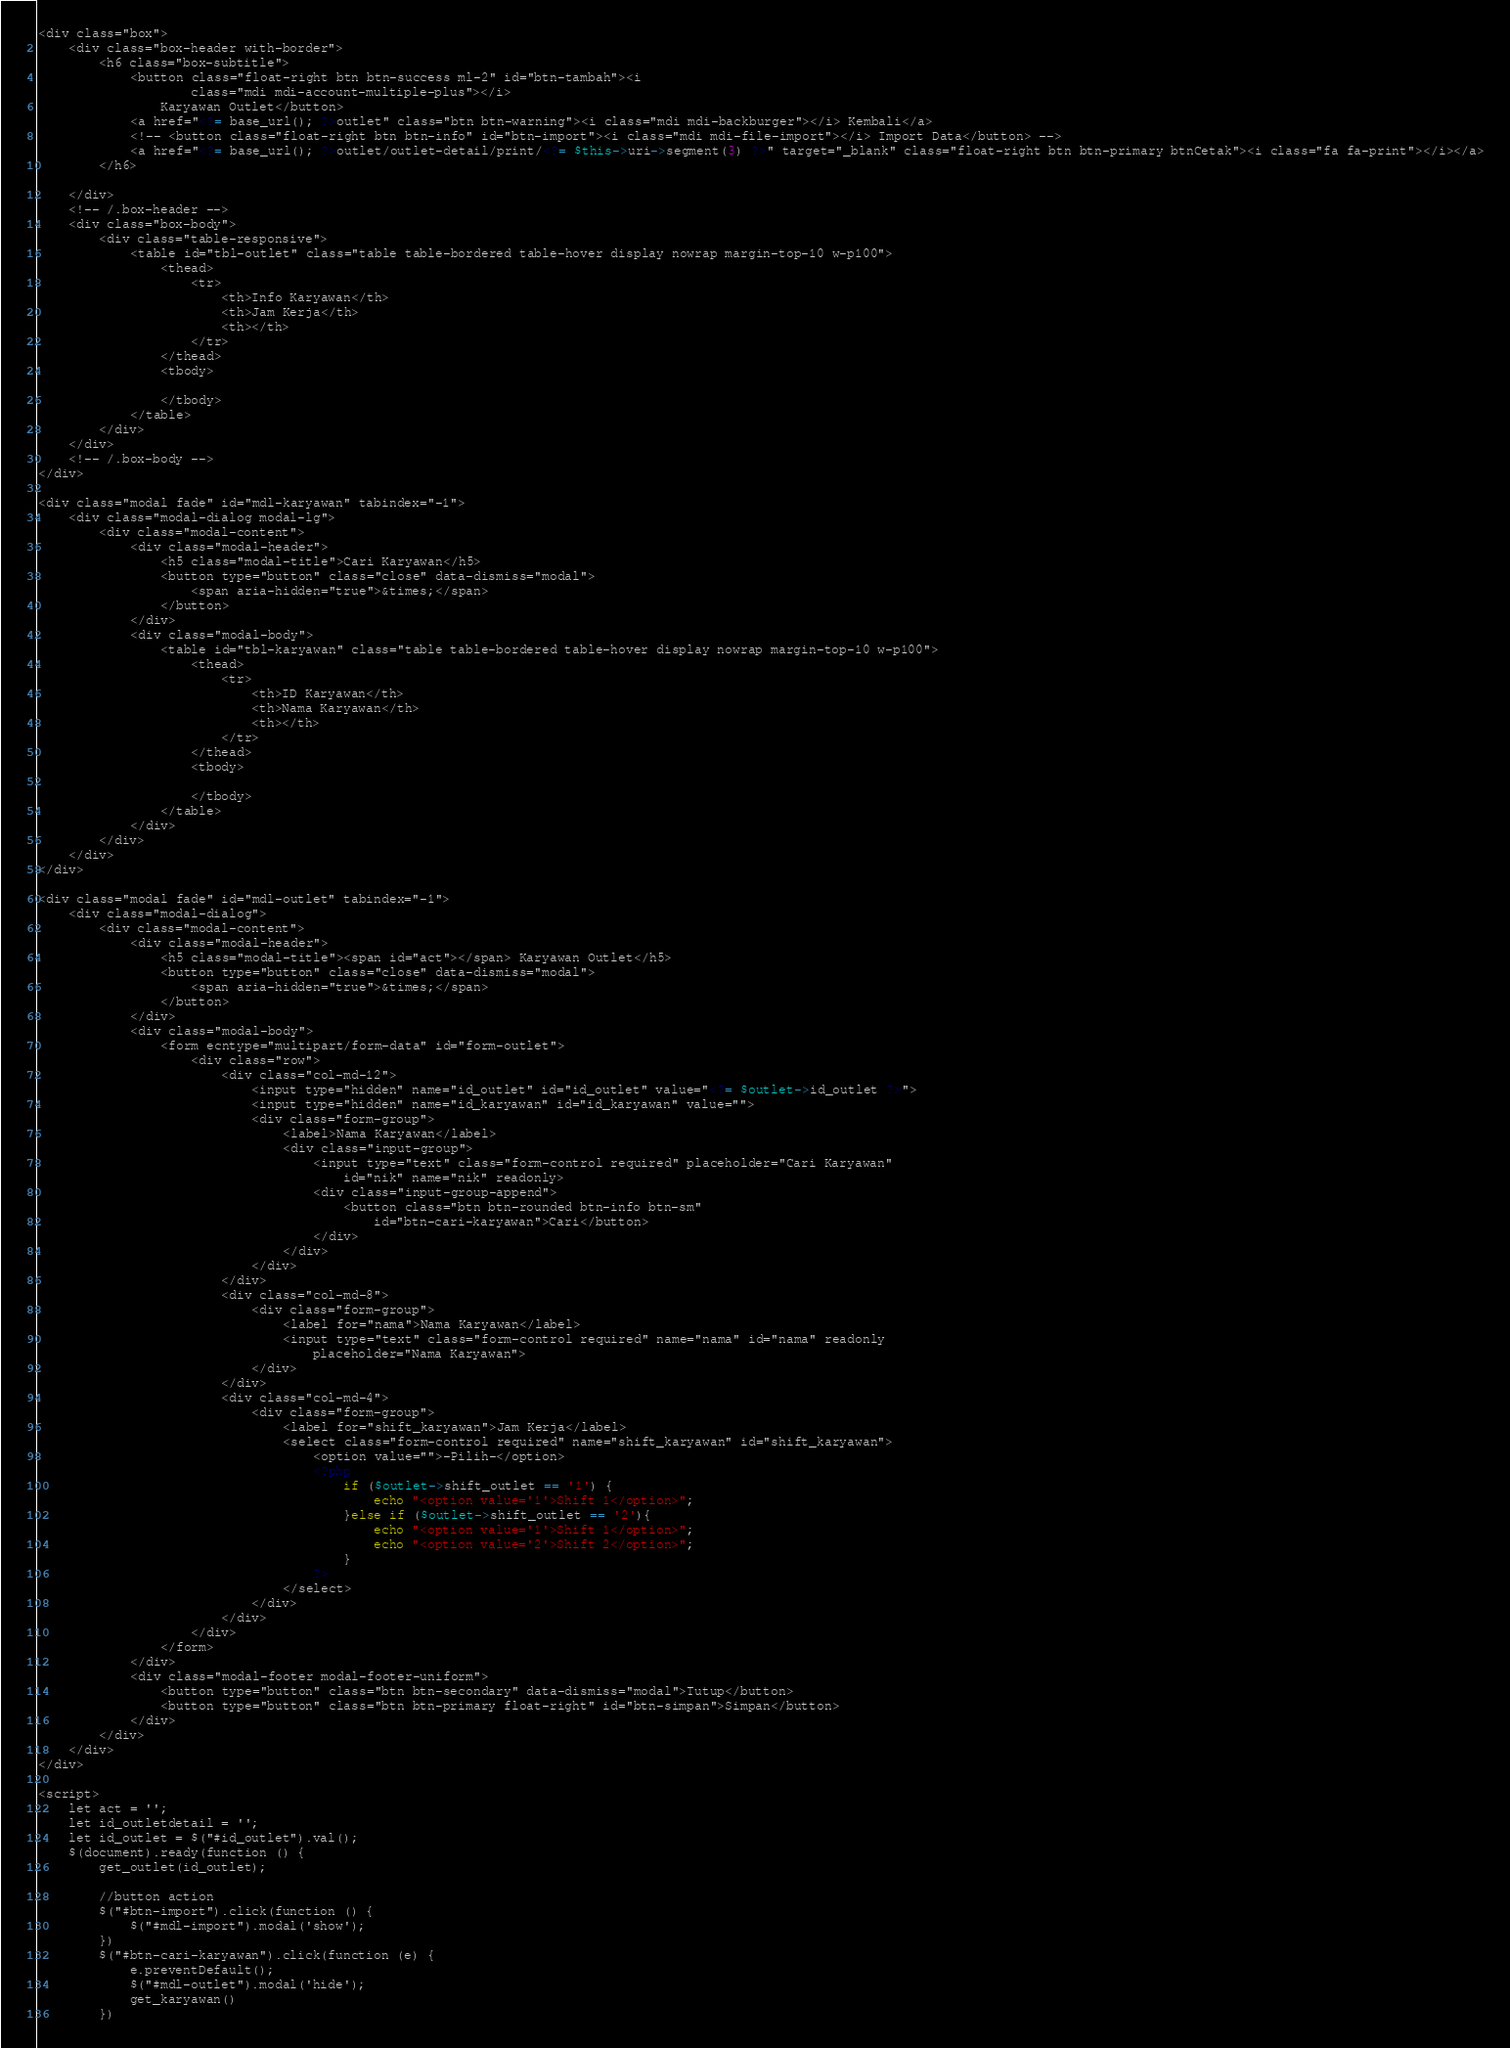Convert code to text. <code><loc_0><loc_0><loc_500><loc_500><_PHP_><div class="box">
	<div class="box-header with-border">
		<h6 class="box-subtitle">
			<button class="float-right btn btn-success ml-2" id="btn-tambah"><i
					class="mdi mdi-account-multiple-plus"></i>
				Karyawan Outlet</button>
			<a href="<?= base_url(); ?>outlet" class="btn btn-warning"><i class="mdi mdi-backburger"></i> Kembali</a>
			<!-- <button class="float-right btn btn-info" id="btn-import"><i class="mdi mdi-file-import"></i> Import Data</button> -->
			<a href="<?= base_url(); ?>outlet/outlet-detail/print/<?= $this->uri->segment(3) ?>" target="_blank" class="float-right btn btn-primary btnCetak"><i class="fa fa-print"></i></a>
		</h6>

	</div>
	<!-- /.box-header -->
	<div class="box-body">
		<div class="table-responsive">
			<table id="tbl-outlet" class="table table-bordered table-hover display nowrap margin-top-10 w-p100">
				<thead>
					<tr>
						<th>Info Karyawan</th>
						<th>Jam Kerja</th>
						<th></th>
					</tr>
				</thead>
				<tbody>

				</tbody>
			</table>
		</div>
	</div>
	<!-- /.box-body -->
</div>

<div class="modal fade" id="mdl-karyawan" tabindex="-1">
	<div class="modal-dialog modal-lg">
		<div class="modal-content">
			<div class="modal-header">
				<h5 class="modal-title">Cari Karyawan</h5>
				<button type="button" class="close" data-dismiss="modal">
					<span aria-hidden="true">&times;</span>
				</button>
			</div>
			<div class="modal-body">
				<table id="tbl-karyawan" class="table table-bordered table-hover display nowrap margin-top-10 w-p100">
					<thead>
						<tr>
							<th>ID Karyawan</th>
							<th>Nama Karyawan</th>
							<th></th>
						</tr>
					</thead>
					<tbody>

					</tbody>
				</table>
			</div>
		</div>
	</div>
</div>

<div class="modal fade" id="mdl-outlet" tabindex="-1">
	<div class="modal-dialog">
		<div class="modal-content">
			<div class="modal-header">
				<h5 class="modal-title"><span id="act"></span> Karyawan Outlet</h5>
				<button type="button" class="close" data-dismiss="modal">
					<span aria-hidden="true">&times;</span>
				</button>
			</div>
			<div class="modal-body">
				<form ecntype="multipart/form-data" id="form-outlet">
					<div class="row">
						<div class="col-md-12">
							<input type="hidden" name="id_outlet" id="id_outlet" value="<?= $outlet->id_outlet ?>">
							<input type="hidden" name="id_karyawan" id="id_karyawan" value="">
							<div class="form-group">
								<label>Nama Karyawan</label>
								<div class="input-group">
									<input type="text" class="form-control required" placeholder="Cari Karyawan"
										id="nik" name="nik" readonly>
									<div class="input-group-append">
										<button class="btn btn-rounded btn-info btn-sm"
											id="btn-cari-karyawan">Cari</button>
									</div>
								</div>
							</div>
						</div>
						<div class="col-md-8">
							<div class="form-group">
								<label for="nama">Nama Karyawan</label>
								<input type="text" class="form-control required" name="nama" id="nama" readonly
									placeholder="Nama Karyawan">
							</div>
						</div>
						<div class="col-md-4">
							<div class="form-group">
								<label for="shift_karyawan">Jam Kerja</label>
								<select class="form-control required" name="shift_karyawan" id="shift_karyawan">
									<option value="">-Pilih-</option>
									<?php
										if ($outlet->shift_outlet == '1') {
											echo "<option value='1'>Shift 1</option>";
										}else if ($outlet->shift_outlet == '2'){
											echo "<option value='1'>Shift 1</option>";
											echo "<option value='2'>Shift 2</option>";
										}
									?>
								</select>
							</div>
						</div>
					</div>
				</form>
			</div>
			<div class="modal-footer modal-footer-uniform">
				<button type="button" class="btn btn-secondary" data-dismiss="modal">Tutup</button>
				<button type="button" class="btn btn-primary float-right" id="btn-simpan">Simpan</button>
			</div>
		</div>
	</div>
</div>

<script>
	let act = '';
	let id_outletdetail = '';
	let id_outlet = $("#id_outlet").val();
	$(document).ready(function () {
		get_outlet(id_outlet);

		//button action
		$("#btn-import").click(function () {
			$("#mdl-import").modal('show');
		})
		$("#btn-cari-karyawan").click(function (e) {
			e.preventDefault();
			$("#mdl-outlet").modal('hide');
			get_karyawan()
		})</code> 